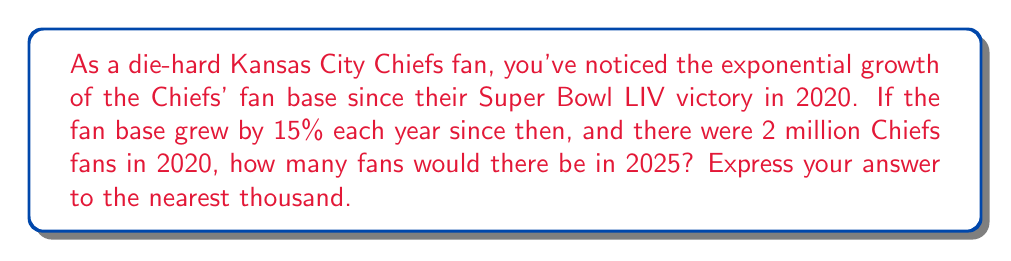Could you help me with this problem? Let's approach this step-by-step:

1) We start with 2 million fans in 2020.
2) The growth rate is 15% per year, which means we multiply by 1.15 each year.
3) We need to calculate this for 5 years (2020 to 2025).

We can express this mathematically as:

$$ 2,000,000 \times (1.15)^5 $$

Let's calculate:

$$ \begin{align}
2,000,000 \times (1.15)^5 &= 2,000,000 \times 2.0113689... \\
&= 4,022,737.8...
\end{align} $$

Rounding to the nearest thousand:

$$ 4,022,737.8... \approx 4,023,000 $$
Answer: $4,023,000$ fans 